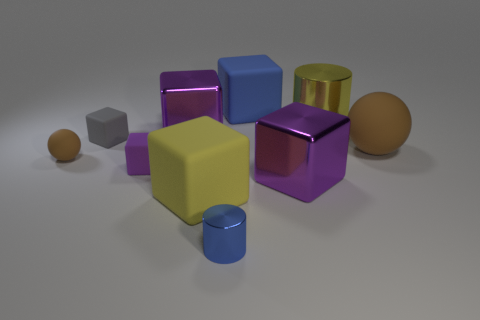What material is the tiny purple cube? While it's difficult to determine the exact material of the tiny purple cube from the image alone, its shiny surface suggests that it could be a plastic or metallic object commonly used in educational or entertainment contexts, like toy building blocks or decorative items. 